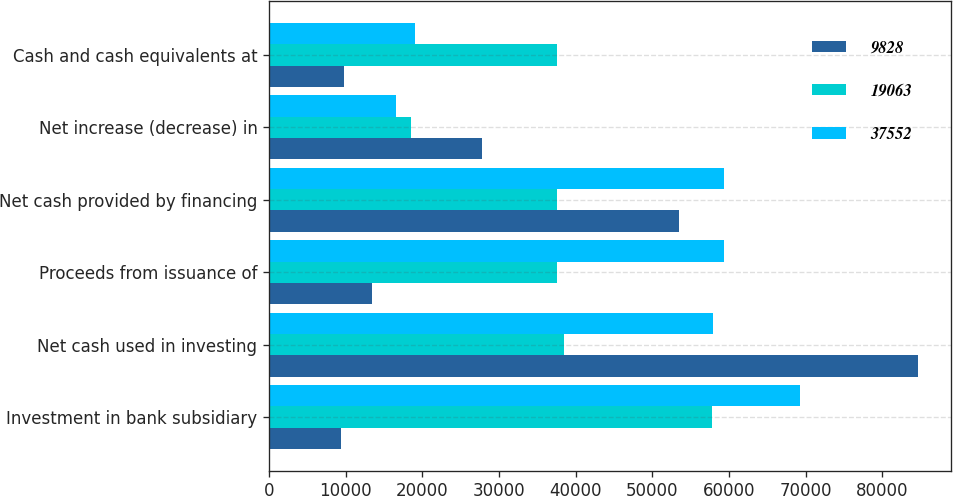Convert chart. <chart><loc_0><loc_0><loc_500><loc_500><stacked_bar_chart><ecel><fcel>Investment in bank subsidiary<fcel>Net cash used in investing<fcel>Proceeds from issuance of<fcel>Net cash provided by financing<fcel>Net increase (decrease) in<fcel>Cash and cash equivalents at<nl><fcel>9828<fcel>9367<fcel>84683<fcel>13363<fcel>53512<fcel>27724<fcel>9828<nl><fcel>19063<fcel>57723<fcel>38478<fcel>37552<fcel>37552<fcel>18489<fcel>37552<nl><fcel>37552<fcel>69200<fcel>57896<fcel>59331<fcel>59331<fcel>16567<fcel>19063<nl></chart> 